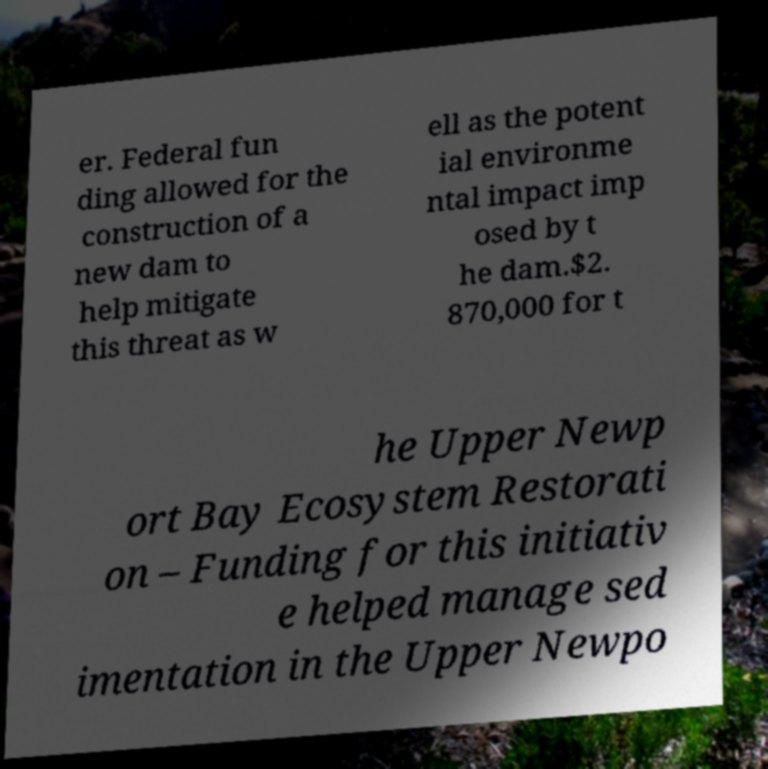Can you accurately transcribe the text from the provided image for me? er. Federal fun ding allowed for the construction of a new dam to help mitigate this threat as w ell as the potent ial environme ntal impact imp osed by t he dam.$2. 870,000 for t he Upper Newp ort Bay Ecosystem Restorati on – Funding for this initiativ e helped manage sed imentation in the Upper Newpo 